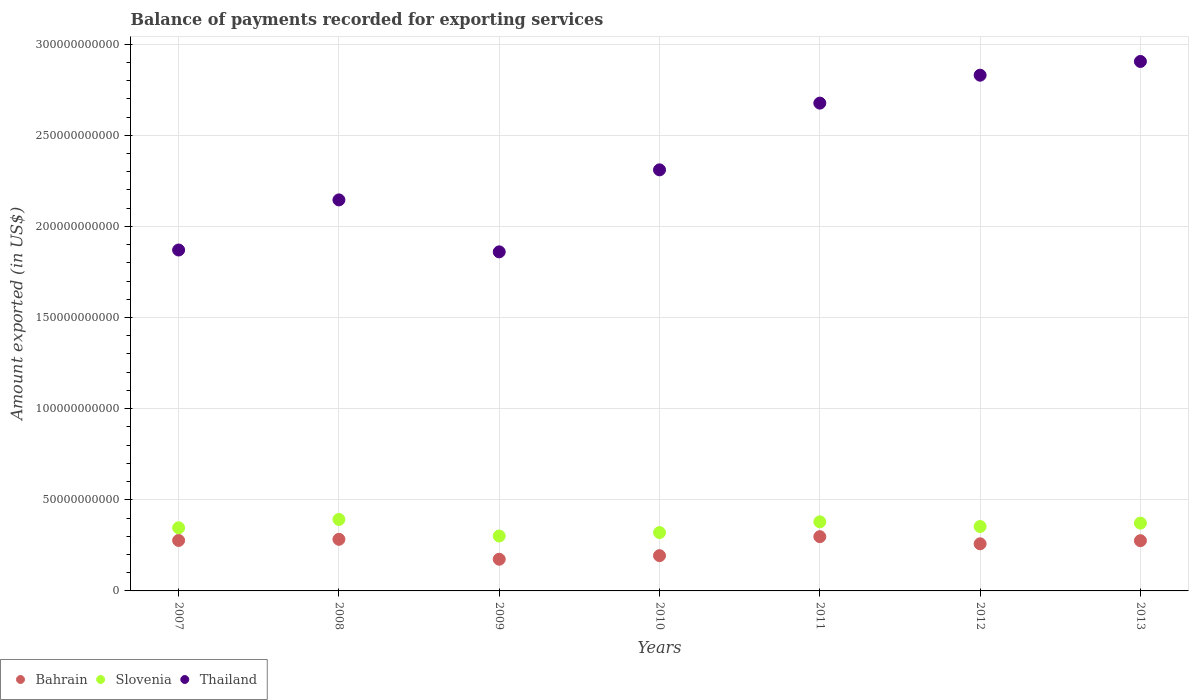How many different coloured dotlines are there?
Your answer should be compact. 3. Is the number of dotlines equal to the number of legend labels?
Provide a succinct answer. Yes. What is the amount exported in Bahrain in 2008?
Provide a succinct answer. 2.83e+1. Across all years, what is the maximum amount exported in Slovenia?
Provide a short and direct response. 3.92e+1. Across all years, what is the minimum amount exported in Bahrain?
Offer a terse response. 1.74e+1. What is the total amount exported in Bahrain in the graph?
Make the answer very short. 1.76e+11. What is the difference between the amount exported in Thailand in 2007 and that in 2012?
Provide a short and direct response. -9.59e+1. What is the difference between the amount exported in Bahrain in 2013 and the amount exported in Thailand in 2012?
Offer a terse response. -2.55e+11. What is the average amount exported in Thailand per year?
Give a very brief answer. 2.37e+11. In the year 2011, what is the difference between the amount exported in Slovenia and amount exported in Bahrain?
Keep it short and to the point. 8.15e+09. In how many years, is the amount exported in Bahrain greater than 290000000000 US$?
Make the answer very short. 0. What is the ratio of the amount exported in Slovenia in 2007 to that in 2012?
Your answer should be compact. 0.98. Is the amount exported in Thailand in 2007 less than that in 2013?
Your response must be concise. Yes. What is the difference between the highest and the second highest amount exported in Thailand?
Provide a succinct answer. 7.53e+09. What is the difference between the highest and the lowest amount exported in Bahrain?
Make the answer very short. 1.24e+1. Is the sum of the amount exported in Slovenia in 2008 and 2009 greater than the maximum amount exported in Thailand across all years?
Your response must be concise. No. Is it the case that in every year, the sum of the amount exported in Bahrain and amount exported in Slovenia  is greater than the amount exported in Thailand?
Provide a short and direct response. No. Is the amount exported in Slovenia strictly greater than the amount exported in Thailand over the years?
Provide a succinct answer. No. How many dotlines are there?
Provide a short and direct response. 3. How many years are there in the graph?
Provide a succinct answer. 7. What is the difference between two consecutive major ticks on the Y-axis?
Ensure brevity in your answer.  5.00e+1. Does the graph contain any zero values?
Your response must be concise. No. Does the graph contain grids?
Provide a succinct answer. Yes. Where does the legend appear in the graph?
Make the answer very short. Bottom left. How many legend labels are there?
Offer a terse response. 3. How are the legend labels stacked?
Give a very brief answer. Horizontal. What is the title of the graph?
Provide a short and direct response. Balance of payments recorded for exporting services. Does "Mexico" appear as one of the legend labels in the graph?
Make the answer very short. No. What is the label or title of the Y-axis?
Offer a very short reply. Amount exported (in US$). What is the Amount exported (in US$) in Bahrain in 2007?
Your response must be concise. 2.77e+1. What is the Amount exported (in US$) of Slovenia in 2007?
Provide a short and direct response. 3.46e+1. What is the Amount exported (in US$) of Thailand in 2007?
Make the answer very short. 1.87e+11. What is the Amount exported (in US$) in Bahrain in 2008?
Ensure brevity in your answer.  2.83e+1. What is the Amount exported (in US$) in Slovenia in 2008?
Provide a short and direct response. 3.92e+1. What is the Amount exported (in US$) in Thailand in 2008?
Your answer should be very brief. 2.15e+11. What is the Amount exported (in US$) in Bahrain in 2009?
Ensure brevity in your answer.  1.74e+1. What is the Amount exported (in US$) in Slovenia in 2009?
Your answer should be compact. 3.01e+1. What is the Amount exported (in US$) in Thailand in 2009?
Your answer should be compact. 1.86e+11. What is the Amount exported (in US$) of Bahrain in 2010?
Offer a very short reply. 1.93e+1. What is the Amount exported (in US$) in Slovenia in 2010?
Make the answer very short. 3.20e+1. What is the Amount exported (in US$) of Thailand in 2010?
Make the answer very short. 2.31e+11. What is the Amount exported (in US$) of Bahrain in 2011?
Provide a succinct answer. 2.98e+1. What is the Amount exported (in US$) in Slovenia in 2011?
Provide a short and direct response. 3.79e+1. What is the Amount exported (in US$) in Thailand in 2011?
Ensure brevity in your answer.  2.68e+11. What is the Amount exported (in US$) in Bahrain in 2012?
Provide a succinct answer. 2.59e+1. What is the Amount exported (in US$) of Slovenia in 2012?
Keep it short and to the point. 3.53e+1. What is the Amount exported (in US$) in Thailand in 2012?
Provide a succinct answer. 2.83e+11. What is the Amount exported (in US$) in Bahrain in 2013?
Your answer should be very brief. 2.76e+1. What is the Amount exported (in US$) of Slovenia in 2013?
Offer a terse response. 3.72e+1. What is the Amount exported (in US$) in Thailand in 2013?
Ensure brevity in your answer.  2.90e+11. Across all years, what is the maximum Amount exported (in US$) of Bahrain?
Keep it short and to the point. 2.98e+1. Across all years, what is the maximum Amount exported (in US$) in Slovenia?
Your answer should be compact. 3.92e+1. Across all years, what is the maximum Amount exported (in US$) of Thailand?
Give a very brief answer. 2.90e+11. Across all years, what is the minimum Amount exported (in US$) in Bahrain?
Provide a succinct answer. 1.74e+1. Across all years, what is the minimum Amount exported (in US$) in Slovenia?
Your answer should be very brief. 3.01e+1. Across all years, what is the minimum Amount exported (in US$) in Thailand?
Keep it short and to the point. 1.86e+11. What is the total Amount exported (in US$) of Bahrain in the graph?
Your answer should be compact. 1.76e+11. What is the total Amount exported (in US$) of Slovenia in the graph?
Make the answer very short. 2.46e+11. What is the total Amount exported (in US$) in Thailand in the graph?
Provide a short and direct response. 1.66e+12. What is the difference between the Amount exported (in US$) of Bahrain in 2007 and that in 2008?
Make the answer very short. -6.31e+08. What is the difference between the Amount exported (in US$) in Slovenia in 2007 and that in 2008?
Give a very brief answer. -4.58e+09. What is the difference between the Amount exported (in US$) in Thailand in 2007 and that in 2008?
Your answer should be very brief. -2.75e+1. What is the difference between the Amount exported (in US$) of Bahrain in 2007 and that in 2009?
Give a very brief answer. 1.03e+1. What is the difference between the Amount exported (in US$) in Slovenia in 2007 and that in 2009?
Your answer should be compact. 4.51e+09. What is the difference between the Amount exported (in US$) in Thailand in 2007 and that in 2009?
Make the answer very short. 1.02e+09. What is the difference between the Amount exported (in US$) of Bahrain in 2007 and that in 2010?
Provide a short and direct response. 8.34e+09. What is the difference between the Amount exported (in US$) in Slovenia in 2007 and that in 2010?
Give a very brief answer. 2.63e+09. What is the difference between the Amount exported (in US$) in Thailand in 2007 and that in 2010?
Provide a succinct answer. -4.40e+1. What is the difference between the Amount exported (in US$) in Bahrain in 2007 and that in 2011?
Provide a succinct answer. -2.08e+09. What is the difference between the Amount exported (in US$) of Slovenia in 2007 and that in 2011?
Provide a succinct answer. -3.27e+09. What is the difference between the Amount exported (in US$) of Thailand in 2007 and that in 2011?
Offer a terse response. -8.06e+1. What is the difference between the Amount exported (in US$) of Bahrain in 2007 and that in 2012?
Your response must be concise. 1.84e+09. What is the difference between the Amount exported (in US$) in Slovenia in 2007 and that in 2012?
Offer a terse response. -7.01e+08. What is the difference between the Amount exported (in US$) in Thailand in 2007 and that in 2012?
Provide a short and direct response. -9.59e+1. What is the difference between the Amount exported (in US$) of Bahrain in 2007 and that in 2013?
Keep it short and to the point. 1.32e+08. What is the difference between the Amount exported (in US$) of Slovenia in 2007 and that in 2013?
Provide a short and direct response. -2.57e+09. What is the difference between the Amount exported (in US$) of Thailand in 2007 and that in 2013?
Keep it short and to the point. -1.03e+11. What is the difference between the Amount exported (in US$) in Bahrain in 2008 and that in 2009?
Your answer should be very brief. 1.09e+1. What is the difference between the Amount exported (in US$) in Slovenia in 2008 and that in 2009?
Make the answer very short. 9.09e+09. What is the difference between the Amount exported (in US$) in Thailand in 2008 and that in 2009?
Keep it short and to the point. 2.85e+1. What is the difference between the Amount exported (in US$) in Bahrain in 2008 and that in 2010?
Offer a very short reply. 8.97e+09. What is the difference between the Amount exported (in US$) in Slovenia in 2008 and that in 2010?
Provide a succinct answer. 7.21e+09. What is the difference between the Amount exported (in US$) in Thailand in 2008 and that in 2010?
Your response must be concise. -1.65e+1. What is the difference between the Amount exported (in US$) of Bahrain in 2008 and that in 2011?
Your response must be concise. -1.45e+09. What is the difference between the Amount exported (in US$) of Slovenia in 2008 and that in 2011?
Your answer should be very brief. 1.31e+09. What is the difference between the Amount exported (in US$) in Thailand in 2008 and that in 2011?
Your answer should be very brief. -5.31e+1. What is the difference between the Amount exported (in US$) of Bahrain in 2008 and that in 2012?
Provide a succinct answer. 2.47e+09. What is the difference between the Amount exported (in US$) of Slovenia in 2008 and that in 2012?
Keep it short and to the point. 3.88e+09. What is the difference between the Amount exported (in US$) in Thailand in 2008 and that in 2012?
Your answer should be very brief. -6.84e+1. What is the difference between the Amount exported (in US$) of Bahrain in 2008 and that in 2013?
Your response must be concise. 7.64e+08. What is the difference between the Amount exported (in US$) in Slovenia in 2008 and that in 2013?
Provide a succinct answer. 2.01e+09. What is the difference between the Amount exported (in US$) in Thailand in 2008 and that in 2013?
Offer a terse response. -7.60e+1. What is the difference between the Amount exported (in US$) of Bahrain in 2009 and that in 2010?
Provide a short and direct response. -1.96e+09. What is the difference between the Amount exported (in US$) of Slovenia in 2009 and that in 2010?
Offer a very short reply. -1.88e+09. What is the difference between the Amount exported (in US$) in Thailand in 2009 and that in 2010?
Offer a very short reply. -4.50e+1. What is the difference between the Amount exported (in US$) of Bahrain in 2009 and that in 2011?
Give a very brief answer. -1.24e+1. What is the difference between the Amount exported (in US$) of Slovenia in 2009 and that in 2011?
Provide a succinct answer. -7.78e+09. What is the difference between the Amount exported (in US$) of Thailand in 2009 and that in 2011?
Make the answer very short. -8.16e+1. What is the difference between the Amount exported (in US$) of Bahrain in 2009 and that in 2012?
Offer a terse response. -8.47e+09. What is the difference between the Amount exported (in US$) in Slovenia in 2009 and that in 2012?
Your response must be concise. -5.21e+09. What is the difference between the Amount exported (in US$) in Thailand in 2009 and that in 2012?
Give a very brief answer. -9.69e+1. What is the difference between the Amount exported (in US$) in Bahrain in 2009 and that in 2013?
Give a very brief answer. -1.02e+1. What is the difference between the Amount exported (in US$) in Slovenia in 2009 and that in 2013?
Your answer should be very brief. -7.07e+09. What is the difference between the Amount exported (in US$) in Thailand in 2009 and that in 2013?
Keep it short and to the point. -1.04e+11. What is the difference between the Amount exported (in US$) of Bahrain in 2010 and that in 2011?
Offer a very short reply. -1.04e+1. What is the difference between the Amount exported (in US$) in Slovenia in 2010 and that in 2011?
Your answer should be compact. -5.90e+09. What is the difference between the Amount exported (in US$) of Thailand in 2010 and that in 2011?
Make the answer very short. -3.66e+1. What is the difference between the Amount exported (in US$) of Bahrain in 2010 and that in 2012?
Your response must be concise. -6.50e+09. What is the difference between the Amount exported (in US$) of Slovenia in 2010 and that in 2012?
Give a very brief answer. -3.33e+09. What is the difference between the Amount exported (in US$) of Thailand in 2010 and that in 2012?
Offer a very short reply. -5.19e+1. What is the difference between the Amount exported (in US$) in Bahrain in 2010 and that in 2013?
Keep it short and to the point. -8.21e+09. What is the difference between the Amount exported (in US$) in Slovenia in 2010 and that in 2013?
Offer a terse response. -5.20e+09. What is the difference between the Amount exported (in US$) of Thailand in 2010 and that in 2013?
Offer a very short reply. -5.95e+1. What is the difference between the Amount exported (in US$) in Bahrain in 2011 and that in 2012?
Provide a succinct answer. 3.92e+09. What is the difference between the Amount exported (in US$) of Slovenia in 2011 and that in 2012?
Your response must be concise. 2.57e+09. What is the difference between the Amount exported (in US$) of Thailand in 2011 and that in 2012?
Give a very brief answer. -1.53e+1. What is the difference between the Amount exported (in US$) in Bahrain in 2011 and that in 2013?
Offer a terse response. 2.21e+09. What is the difference between the Amount exported (in US$) in Slovenia in 2011 and that in 2013?
Provide a short and direct response. 7.06e+08. What is the difference between the Amount exported (in US$) in Thailand in 2011 and that in 2013?
Ensure brevity in your answer.  -2.29e+1. What is the difference between the Amount exported (in US$) of Bahrain in 2012 and that in 2013?
Offer a terse response. -1.70e+09. What is the difference between the Amount exported (in US$) in Slovenia in 2012 and that in 2013?
Ensure brevity in your answer.  -1.87e+09. What is the difference between the Amount exported (in US$) of Thailand in 2012 and that in 2013?
Offer a terse response. -7.53e+09. What is the difference between the Amount exported (in US$) of Bahrain in 2007 and the Amount exported (in US$) of Slovenia in 2008?
Offer a terse response. -1.15e+1. What is the difference between the Amount exported (in US$) in Bahrain in 2007 and the Amount exported (in US$) in Thailand in 2008?
Provide a succinct answer. -1.87e+11. What is the difference between the Amount exported (in US$) in Slovenia in 2007 and the Amount exported (in US$) in Thailand in 2008?
Ensure brevity in your answer.  -1.80e+11. What is the difference between the Amount exported (in US$) in Bahrain in 2007 and the Amount exported (in US$) in Slovenia in 2009?
Your answer should be compact. -2.45e+09. What is the difference between the Amount exported (in US$) in Bahrain in 2007 and the Amount exported (in US$) in Thailand in 2009?
Offer a very short reply. -1.58e+11. What is the difference between the Amount exported (in US$) in Slovenia in 2007 and the Amount exported (in US$) in Thailand in 2009?
Keep it short and to the point. -1.51e+11. What is the difference between the Amount exported (in US$) of Bahrain in 2007 and the Amount exported (in US$) of Slovenia in 2010?
Provide a succinct answer. -4.32e+09. What is the difference between the Amount exported (in US$) in Bahrain in 2007 and the Amount exported (in US$) in Thailand in 2010?
Provide a succinct answer. -2.03e+11. What is the difference between the Amount exported (in US$) of Slovenia in 2007 and the Amount exported (in US$) of Thailand in 2010?
Your answer should be compact. -1.96e+11. What is the difference between the Amount exported (in US$) of Bahrain in 2007 and the Amount exported (in US$) of Slovenia in 2011?
Provide a short and direct response. -1.02e+1. What is the difference between the Amount exported (in US$) of Bahrain in 2007 and the Amount exported (in US$) of Thailand in 2011?
Keep it short and to the point. -2.40e+11. What is the difference between the Amount exported (in US$) in Slovenia in 2007 and the Amount exported (in US$) in Thailand in 2011?
Your answer should be compact. -2.33e+11. What is the difference between the Amount exported (in US$) in Bahrain in 2007 and the Amount exported (in US$) in Slovenia in 2012?
Offer a very short reply. -7.65e+09. What is the difference between the Amount exported (in US$) of Bahrain in 2007 and the Amount exported (in US$) of Thailand in 2012?
Provide a short and direct response. -2.55e+11. What is the difference between the Amount exported (in US$) of Slovenia in 2007 and the Amount exported (in US$) of Thailand in 2012?
Ensure brevity in your answer.  -2.48e+11. What is the difference between the Amount exported (in US$) in Bahrain in 2007 and the Amount exported (in US$) in Slovenia in 2013?
Make the answer very short. -9.52e+09. What is the difference between the Amount exported (in US$) in Bahrain in 2007 and the Amount exported (in US$) in Thailand in 2013?
Provide a short and direct response. -2.63e+11. What is the difference between the Amount exported (in US$) in Slovenia in 2007 and the Amount exported (in US$) in Thailand in 2013?
Keep it short and to the point. -2.56e+11. What is the difference between the Amount exported (in US$) in Bahrain in 2008 and the Amount exported (in US$) in Slovenia in 2009?
Give a very brief answer. -1.81e+09. What is the difference between the Amount exported (in US$) in Bahrain in 2008 and the Amount exported (in US$) in Thailand in 2009?
Provide a short and direct response. -1.58e+11. What is the difference between the Amount exported (in US$) of Slovenia in 2008 and the Amount exported (in US$) of Thailand in 2009?
Offer a very short reply. -1.47e+11. What is the difference between the Amount exported (in US$) in Bahrain in 2008 and the Amount exported (in US$) in Slovenia in 2010?
Your answer should be very brief. -3.69e+09. What is the difference between the Amount exported (in US$) in Bahrain in 2008 and the Amount exported (in US$) in Thailand in 2010?
Offer a very short reply. -2.03e+11. What is the difference between the Amount exported (in US$) of Slovenia in 2008 and the Amount exported (in US$) of Thailand in 2010?
Offer a terse response. -1.92e+11. What is the difference between the Amount exported (in US$) in Bahrain in 2008 and the Amount exported (in US$) in Slovenia in 2011?
Provide a succinct answer. -9.59e+09. What is the difference between the Amount exported (in US$) in Bahrain in 2008 and the Amount exported (in US$) in Thailand in 2011?
Give a very brief answer. -2.39e+11. What is the difference between the Amount exported (in US$) of Slovenia in 2008 and the Amount exported (in US$) of Thailand in 2011?
Offer a very short reply. -2.28e+11. What is the difference between the Amount exported (in US$) of Bahrain in 2008 and the Amount exported (in US$) of Slovenia in 2012?
Your response must be concise. -7.02e+09. What is the difference between the Amount exported (in US$) of Bahrain in 2008 and the Amount exported (in US$) of Thailand in 2012?
Your answer should be compact. -2.55e+11. What is the difference between the Amount exported (in US$) of Slovenia in 2008 and the Amount exported (in US$) of Thailand in 2012?
Your response must be concise. -2.44e+11. What is the difference between the Amount exported (in US$) in Bahrain in 2008 and the Amount exported (in US$) in Slovenia in 2013?
Provide a short and direct response. -8.89e+09. What is the difference between the Amount exported (in US$) of Bahrain in 2008 and the Amount exported (in US$) of Thailand in 2013?
Provide a short and direct response. -2.62e+11. What is the difference between the Amount exported (in US$) in Slovenia in 2008 and the Amount exported (in US$) in Thailand in 2013?
Your answer should be compact. -2.51e+11. What is the difference between the Amount exported (in US$) of Bahrain in 2009 and the Amount exported (in US$) of Slovenia in 2010?
Your answer should be very brief. -1.46e+1. What is the difference between the Amount exported (in US$) of Bahrain in 2009 and the Amount exported (in US$) of Thailand in 2010?
Make the answer very short. -2.14e+11. What is the difference between the Amount exported (in US$) in Slovenia in 2009 and the Amount exported (in US$) in Thailand in 2010?
Your response must be concise. -2.01e+11. What is the difference between the Amount exported (in US$) in Bahrain in 2009 and the Amount exported (in US$) in Slovenia in 2011?
Your answer should be very brief. -2.05e+1. What is the difference between the Amount exported (in US$) of Bahrain in 2009 and the Amount exported (in US$) of Thailand in 2011?
Provide a succinct answer. -2.50e+11. What is the difference between the Amount exported (in US$) of Slovenia in 2009 and the Amount exported (in US$) of Thailand in 2011?
Ensure brevity in your answer.  -2.37e+11. What is the difference between the Amount exported (in US$) in Bahrain in 2009 and the Amount exported (in US$) in Slovenia in 2012?
Make the answer very short. -1.80e+1. What is the difference between the Amount exported (in US$) of Bahrain in 2009 and the Amount exported (in US$) of Thailand in 2012?
Provide a succinct answer. -2.66e+11. What is the difference between the Amount exported (in US$) in Slovenia in 2009 and the Amount exported (in US$) in Thailand in 2012?
Give a very brief answer. -2.53e+11. What is the difference between the Amount exported (in US$) in Bahrain in 2009 and the Amount exported (in US$) in Slovenia in 2013?
Give a very brief answer. -1.98e+1. What is the difference between the Amount exported (in US$) in Bahrain in 2009 and the Amount exported (in US$) in Thailand in 2013?
Offer a very short reply. -2.73e+11. What is the difference between the Amount exported (in US$) in Slovenia in 2009 and the Amount exported (in US$) in Thailand in 2013?
Offer a very short reply. -2.60e+11. What is the difference between the Amount exported (in US$) in Bahrain in 2010 and the Amount exported (in US$) in Slovenia in 2011?
Your answer should be very brief. -1.86e+1. What is the difference between the Amount exported (in US$) of Bahrain in 2010 and the Amount exported (in US$) of Thailand in 2011?
Keep it short and to the point. -2.48e+11. What is the difference between the Amount exported (in US$) of Slovenia in 2010 and the Amount exported (in US$) of Thailand in 2011?
Offer a terse response. -2.36e+11. What is the difference between the Amount exported (in US$) of Bahrain in 2010 and the Amount exported (in US$) of Slovenia in 2012?
Offer a terse response. -1.60e+1. What is the difference between the Amount exported (in US$) in Bahrain in 2010 and the Amount exported (in US$) in Thailand in 2012?
Offer a terse response. -2.64e+11. What is the difference between the Amount exported (in US$) in Slovenia in 2010 and the Amount exported (in US$) in Thailand in 2012?
Ensure brevity in your answer.  -2.51e+11. What is the difference between the Amount exported (in US$) of Bahrain in 2010 and the Amount exported (in US$) of Slovenia in 2013?
Provide a short and direct response. -1.79e+1. What is the difference between the Amount exported (in US$) of Bahrain in 2010 and the Amount exported (in US$) of Thailand in 2013?
Offer a terse response. -2.71e+11. What is the difference between the Amount exported (in US$) in Slovenia in 2010 and the Amount exported (in US$) in Thailand in 2013?
Provide a succinct answer. -2.58e+11. What is the difference between the Amount exported (in US$) of Bahrain in 2011 and the Amount exported (in US$) of Slovenia in 2012?
Offer a very short reply. -5.57e+09. What is the difference between the Amount exported (in US$) of Bahrain in 2011 and the Amount exported (in US$) of Thailand in 2012?
Your response must be concise. -2.53e+11. What is the difference between the Amount exported (in US$) in Slovenia in 2011 and the Amount exported (in US$) in Thailand in 2012?
Offer a terse response. -2.45e+11. What is the difference between the Amount exported (in US$) in Bahrain in 2011 and the Amount exported (in US$) in Slovenia in 2013?
Your answer should be very brief. -7.44e+09. What is the difference between the Amount exported (in US$) of Bahrain in 2011 and the Amount exported (in US$) of Thailand in 2013?
Offer a terse response. -2.61e+11. What is the difference between the Amount exported (in US$) of Slovenia in 2011 and the Amount exported (in US$) of Thailand in 2013?
Offer a very short reply. -2.53e+11. What is the difference between the Amount exported (in US$) of Bahrain in 2012 and the Amount exported (in US$) of Slovenia in 2013?
Give a very brief answer. -1.14e+1. What is the difference between the Amount exported (in US$) in Bahrain in 2012 and the Amount exported (in US$) in Thailand in 2013?
Your response must be concise. -2.65e+11. What is the difference between the Amount exported (in US$) in Slovenia in 2012 and the Amount exported (in US$) in Thailand in 2013?
Your response must be concise. -2.55e+11. What is the average Amount exported (in US$) of Bahrain per year?
Offer a terse response. 2.51e+1. What is the average Amount exported (in US$) of Slovenia per year?
Ensure brevity in your answer.  3.52e+1. What is the average Amount exported (in US$) of Thailand per year?
Provide a succinct answer. 2.37e+11. In the year 2007, what is the difference between the Amount exported (in US$) in Bahrain and Amount exported (in US$) in Slovenia?
Offer a very short reply. -6.95e+09. In the year 2007, what is the difference between the Amount exported (in US$) in Bahrain and Amount exported (in US$) in Thailand?
Keep it short and to the point. -1.59e+11. In the year 2007, what is the difference between the Amount exported (in US$) of Slovenia and Amount exported (in US$) of Thailand?
Your answer should be compact. -1.52e+11. In the year 2008, what is the difference between the Amount exported (in US$) in Bahrain and Amount exported (in US$) in Slovenia?
Your response must be concise. -1.09e+1. In the year 2008, what is the difference between the Amount exported (in US$) of Bahrain and Amount exported (in US$) of Thailand?
Provide a succinct answer. -1.86e+11. In the year 2008, what is the difference between the Amount exported (in US$) in Slovenia and Amount exported (in US$) in Thailand?
Give a very brief answer. -1.75e+11. In the year 2009, what is the difference between the Amount exported (in US$) in Bahrain and Amount exported (in US$) in Slovenia?
Give a very brief answer. -1.27e+1. In the year 2009, what is the difference between the Amount exported (in US$) in Bahrain and Amount exported (in US$) in Thailand?
Give a very brief answer. -1.69e+11. In the year 2009, what is the difference between the Amount exported (in US$) in Slovenia and Amount exported (in US$) in Thailand?
Provide a short and direct response. -1.56e+11. In the year 2010, what is the difference between the Amount exported (in US$) of Bahrain and Amount exported (in US$) of Slovenia?
Ensure brevity in your answer.  -1.27e+1. In the year 2010, what is the difference between the Amount exported (in US$) in Bahrain and Amount exported (in US$) in Thailand?
Provide a short and direct response. -2.12e+11. In the year 2010, what is the difference between the Amount exported (in US$) of Slovenia and Amount exported (in US$) of Thailand?
Make the answer very short. -1.99e+11. In the year 2011, what is the difference between the Amount exported (in US$) of Bahrain and Amount exported (in US$) of Slovenia?
Your response must be concise. -8.15e+09. In the year 2011, what is the difference between the Amount exported (in US$) of Bahrain and Amount exported (in US$) of Thailand?
Offer a terse response. -2.38e+11. In the year 2011, what is the difference between the Amount exported (in US$) in Slovenia and Amount exported (in US$) in Thailand?
Your answer should be compact. -2.30e+11. In the year 2012, what is the difference between the Amount exported (in US$) of Bahrain and Amount exported (in US$) of Slovenia?
Ensure brevity in your answer.  -9.49e+09. In the year 2012, what is the difference between the Amount exported (in US$) of Bahrain and Amount exported (in US$) of Thailand?
Ensure brevity in your answer.  -2.57e+11. In the year 2012, what is the difference between the Amount exported (in US$) of Slovenia and Amount exported (in US$) of Thailand?
Provide a succinct answer. -2.48e+11. In the year 2013, what is the difference between the Amount exported (in US$) of Bahrain and Amount exported (in US$) of Slovenia?
Ensure brevity in your answer.  -9.65e+09. In the year 2013, what is the difference between the Amount exported (in US$) of Bahrain and Amount exported (in US$) of Thailand?
Provide a short and direct response. -2.63e+11. In the year 2013, what is the difference between the Amount exported (in US$) of Slovenia and Amount exported (in US$) of Thailand?
Keep it short and to the point. -2.53e+11. What is the ratio of the Amount exported (in US$) in Bahrain in 2007 to that in 2008?
Ensure brevity in your answer.  0.98. What is the ratio of the Amount exported (in US$) of Slovenia in 2007 to that in 2008?
Your answer should be compact. 0.88. What is the ratio of the Amount exported (in US$) in Thailand in 2007 to that in 2008?
Make the answer very short. 0.87. What is the ratio of the Amount exported (in US$) in Bahrain in 2007 to that in 2009?
Provide a short and direct response. 1.59. What is the ratio of the Amount exported (in US$) of Slovenia in 2007 to that in 2009?
Your answer should be very brief. 1.15. What is the ratio of the Amount exported (in US$) of Thailand in 2007 to that in 2009?
Ensure brevity in your answer.  1.01. What is the ratio of the Amount exported (in US$) in Bahrain in 2007 to that in 2010?
Keep it short and to the point. 1.43. What is the ratio of the Amount exported (in US$) of Slovenia in 2007 to that in 2010?
Give a very brief answer. 1.08. What is the ratio of the Amount exported (in US$) in Thailand in 2007 to that in 2010?
Offer a terse response. 0.81. What is the ratio of the Amount exported (in US$) of Bahrain in 2007 to that in 2011?
Offer a terse response. 0.93. What is the ratio of the Amount exported (in US$) of Slovenia in 2007 to that in 2011?
Your answer should be compact. 0.91. What is the ratio of the Amount exported (in US$) in Thailand in 2007 to that in 2011?
Offer a very short reply. 0.7. What is the ratio of the Amount exported (in US$) in Bahrain in 2007 to that in 2012?
Provide a succinct answer. 1.07. What is the ratio of the Amount exported (in US$) in Slovenia in 2007 to that in 2012?
Provide a short and direct response. 0.98. What is the ratio of the Amount exported (in US$) in Thailand in 2007 to that in 2012?
Keep it short and to the point. 0.66. What is the ratio of the Amount exported (in US$) in Bahrain in 2007 to that in 2013?
Offer a terse response. 1. What is the ratio of the Amount exported (in US$) in Thailand in 2007 to that in 2013?
Give a very brief answer. 0.64. What is the ratio of the Amount exported (in US$) in Bahrain in 2008 to that in 2009?
Offer a terse response. 1.63. What is the ratio of the Amount exported (in US$) in Slovenia in 2008 to that in 2009?
Give a very brief answer. 1.3. What is the ratio of the Amount exported (in US$) in Thailand in 2008 to that in 2009?
Your answer should be very brief. 1.15. What is the ratio of the Amount exported (in US$) in Bahrain in 2008 to that in 2010?
Provide a short and direct response. 1.46. What is the ratio of the Amount exported (in US$) in Slovenia in 2008 to that in 2010?
Offer a very short reply. 1.23. What is the ratio of the Amount exported (in US$) of Thailand in 2008 to that in 2010?
Offer a terse response. 0.93. What is the ratio of the Amount exported (in US$) of Bahrain in 2008 to that in 2011?
Provide a succinct answer. 0.95. What is the ratio of the Amount exported (in US$) in Slovenia in 2008 to that in 2011?
Ensure brevity in your answer.  1.03. What is the ratio of the Amount exported (in US$) in Thailand in 2008 to that in 2011?
Your answer should be very brief. 0.8. What is the ratio of the Amount exported (in US$) in Bahrain in 2008 to that in 2012?
Give a very brief answer. 1.1. What is the ratio of the Amount exported (in US$) in Slovenia in 2008 to that in 2012?
Offer a very short reply. 1.11. What is the ratio of the Amount exported (in US$) of Thailand in 2008 to that in 2012?
Make the answer very short. 0.76. What is the ratio of the Amount exported (in US$) in Bahrain in 2008 to that in 2013?
Offer a very short reply. 1.03. What is the ratio of the Amount exported (in US$) in Slovenia in 2008 to that in 2013?
Your answer should be very brief. 1.05. What is the ratio of the Amount exported (in US$) in Thailand in 2008 to that in 2013?
Provide a short and direct response. 0.74. What is the ratio of the Amount exported (in US$) of Bahrain in 2009 to that in 2010?
Your response must be concise. 0.9. What is the ratio of the Amount exported (in US$) in Slovenia in 2009 to that in 2010?
Give a very brief answer. 0.94. What is the ratio of the Amount exported (in US$) in Thailand in 2009 to that in 2010?
Give a very brief answer. 0.81. What is the ratio of the Amount exported (in US$) of Bahrain in 2009 to that in 2011?
Your answer should be very brief. 0.58. What is the ratio of the Amount exported (in US$) of Slovenia in 2009 to that in 2011?
Ensure brevity in your answer.  0.79. What is the ratio of the Amount exported (in US$) of Thailand in 2009 to that in 2011?
Keep it short and to the point. 0.7. What is the ratio of the Amount exported (in US$) in Bahrain in 2009 to that in 2012?
Make the answer very short. 0.67. What is the ratio of the Amount exported (in US$) of Slovenia in 2009 to that in 2012?
Keep it short and to the point. 0.85. What is the ratio of the Amount exported (in US$) in Thailand in 2009 to that in 2012?
Keep it short and to the point. 0.66. What is the ratio of the Amount exported (in US$) in Bahrain in 2009 to that in 2013?
Your answer should be very brief. 0.63. What is the ratio of the Amount exported (in US$) in Slovenia in 2009 to that in 2013?
Make the answer very short. 0.81. What is the ratio of the Amount exported (in US$) of Thailand in 2009 to that in 2013?
Your answer should be compact. 0.64. What is the ratio of the Amount exported (in US$) in Bahrain in 2010 to that in 2011?
Provide a short and direct response. 0.65. What is the ratio of the Amount exported (in US$) in Slovenia in 2010 to that in 2011?
Keep it short and to the point. 0.84. What is the ratio of the Amount exported (in US$) of Thailand in 2010 to that in 2011?
Keep it short and to the point. 0.86. What is the ratio of the Amount exported (in US$) in Bahrain in 2010 to that in 2012?
Ensure brevity in your answer.  0.75. What is the ratio of the Amount exported (in US$) of Slovenia in 2010 to that in 2012?
Give a very brief answer. 0.91. What is the ratio of the Amount exported (in US$) of Thailand in 2010 to that in 2012?
Give a very brief answer. 0.82. What is the ratio of the Amount exported (in US$) in Bahrain in 2010 to that in 2013?
Offer a terse response. 0.7. What is the ratio of the Amount exported (in US$) of Slovenia in 2010 to that in 2013?
Your answer should be compact. 0.86. What is the ratio of the Amount exported (in US$) of Thailand in 2010 to that in 2013?
Your answer should be compact. 0.8. What is the ratio of the Amount exported (in US$) in Bahrain in 2011 to that in 2012?
Provide a short and direct response. 1.15. What is the ratio of the Amount exported (in US$) of Slovenia in 2011 to that in 2012?
Your response must be concise. 1.07. What is the ratio of the Amount exported (in US$) of Thailand in 2011 to that in 2012?
Offer a very short reply. 0.95. What is the ratio of the Amount exported (in US$) in Bahrain in 2011 to that in 2013?
Offer a very short reply. 1.08. What is the ratio of the Amount exported (in US$) of Slovenia in 2011 to that in 2013?
Make the answer very short. 1.02. What is the ratio of the Amount exported (in US$) in Thailand in 2011 to that in 2013?
Provide a short and direct response. 0.92. What is the ratio of the Amount exported (in US$) in Bahrain in 2012 to that in 2013?
Offer a terse response. 0.94. What is the ratio of the Amount exported (in US$) of Slovenia in 2012 to that in 2013?
Give a very brief answer. 0.95. What is the ratio of the Amount exported (in US$) in Thailand in 2012 to that in 2013?
Provide a succinct answer. 0.97. What is the difference between the highest and the second highest Amount exported (in US$) of Bahrain?
Your response must be concise. 1.45e+09. What is the difference between the highest and the second highest Amount exported (in US$) of Slovenia?
Your answer should be very brief. 1.31e+09. What is the difference between the highest and the second highest Amount exported (in US$) of Thailand?
Ensure brevity in your answer.  7.53e+09. What is the difference between the highest and the lowest Amount exported (in US$) in Bahrain?
Provide a succinct answer. 1.24e+1. What is the difference between the highest and the lowest Amount exported (in US$) of Slovenia?
Your response must be concise. 9.09e+09. What is the difference between the highest and the lowest Amount exported (in US$) in Thailand?
Provide a succinct answer. 1.04e+11. 